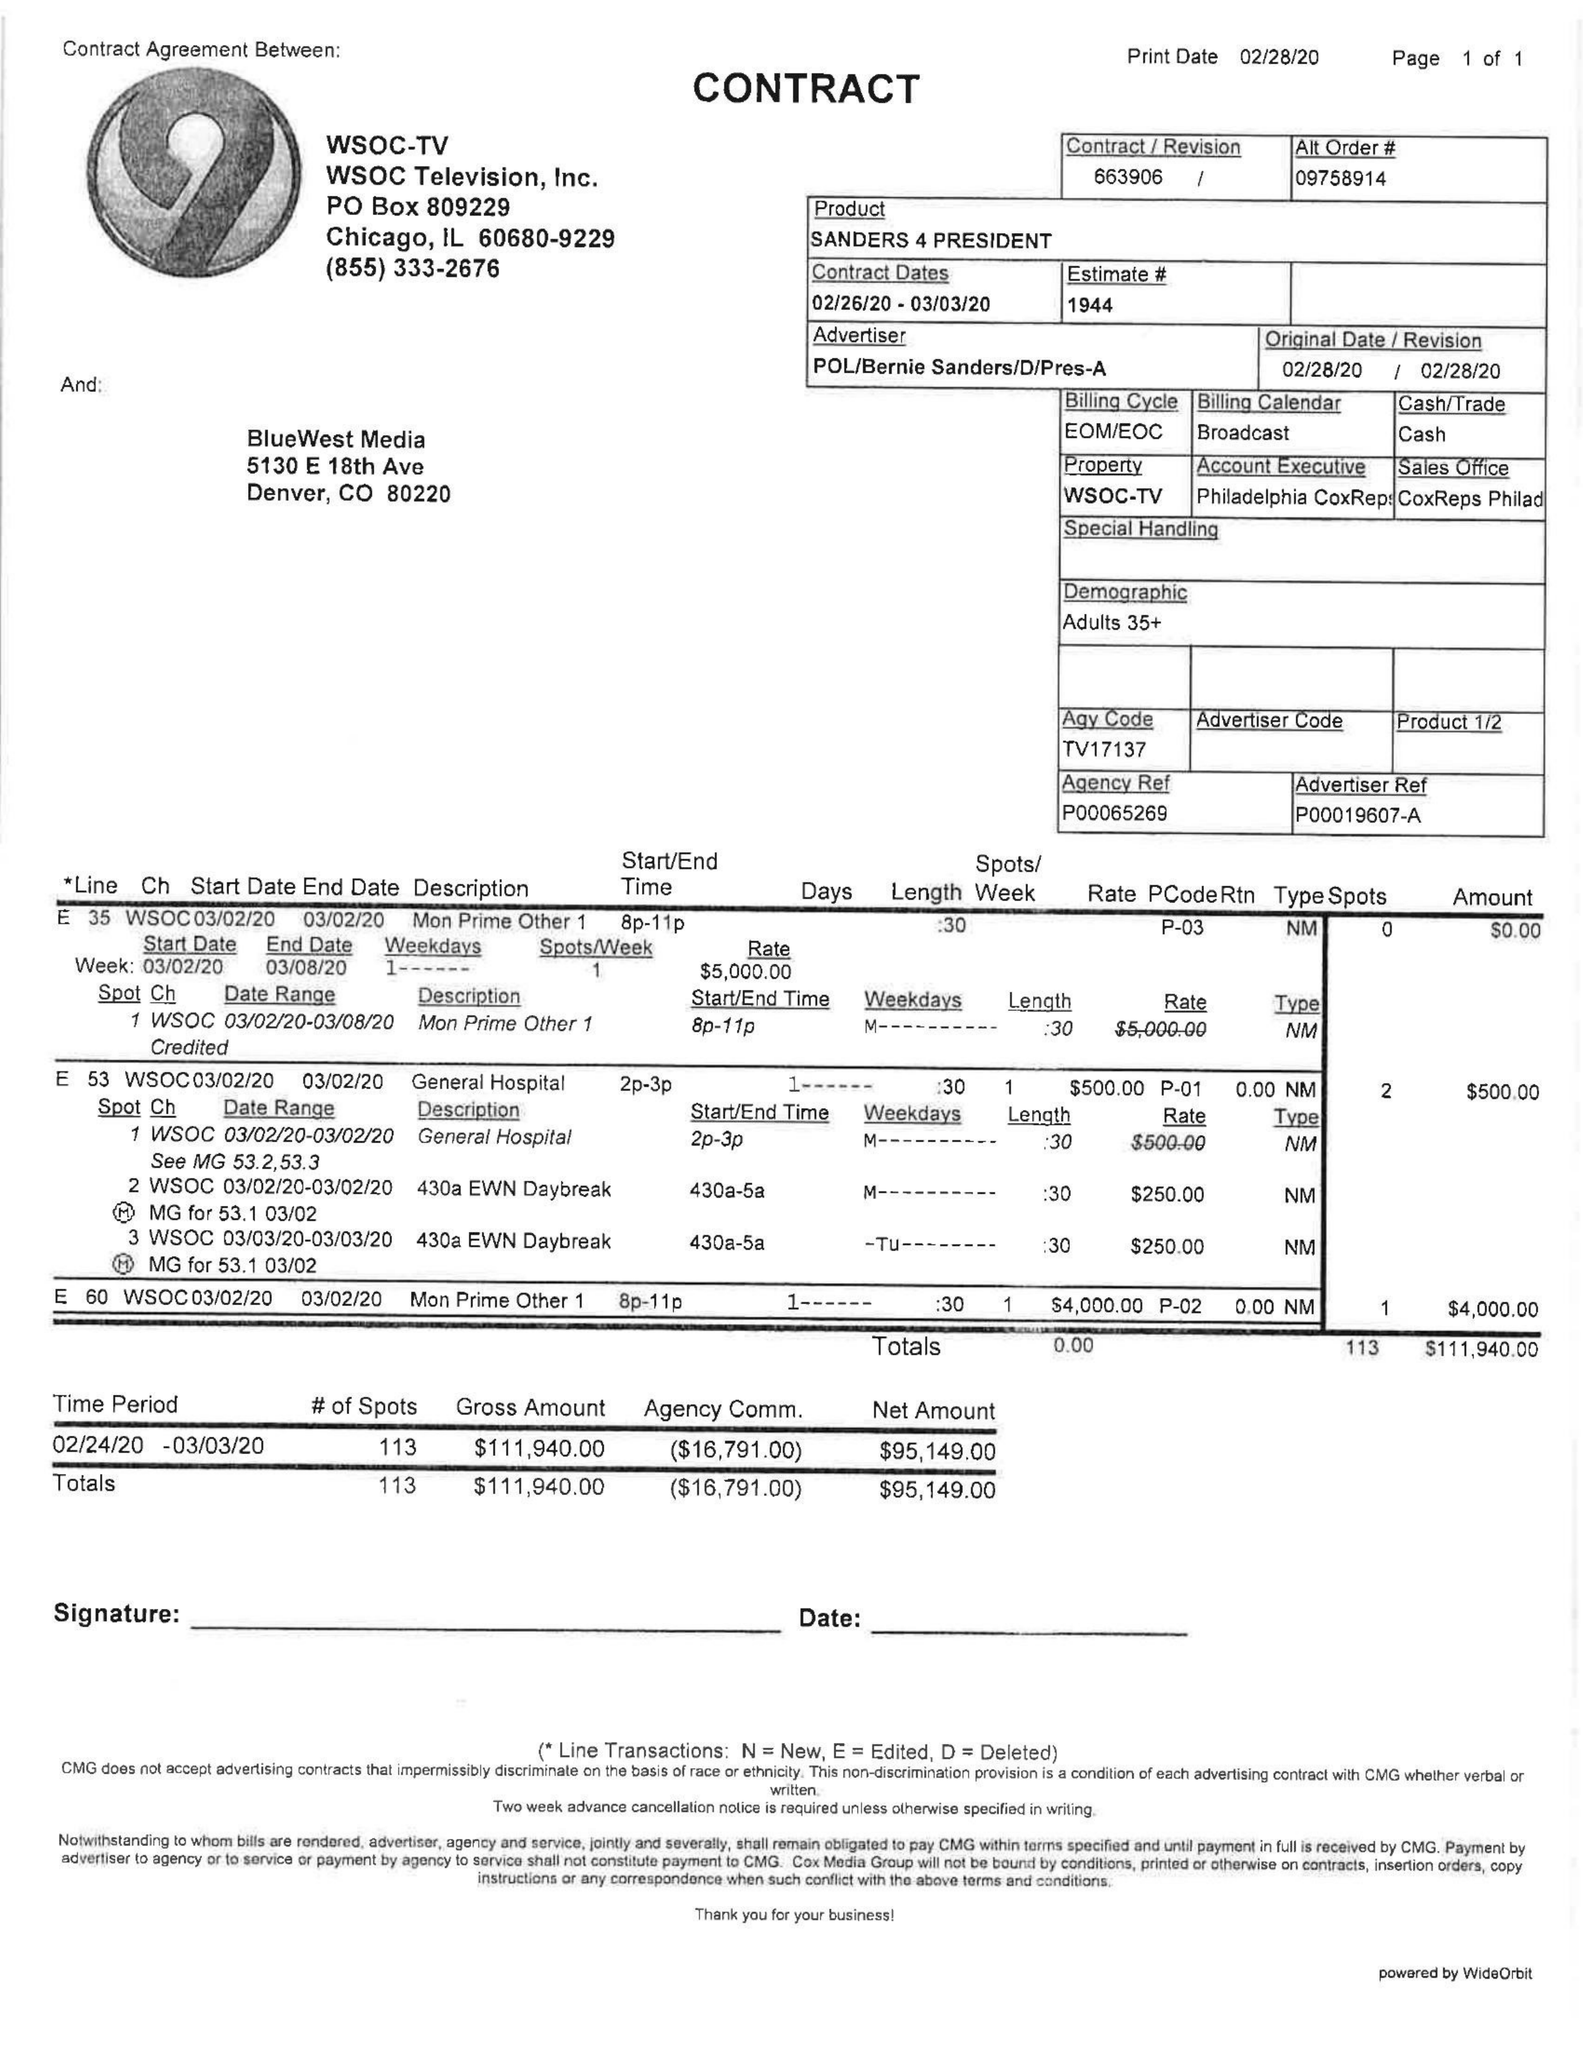What is the value for the flight_to?
Answer the question using a single word or phrase. 03/03/20 